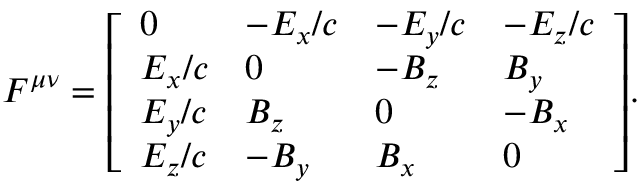Convert formula to latex. <formula><loc_0><loc_0><loc_500><loc_500>F ^ { \mu \nu } = { \left [ \begin{array} { l l l l } { 0 } & { - E _ { x } / c } & { - E _ { y } / c } & { - E _ { z } / c } \\ { E _ { x } / c } & { 0 } & { - B _ { z } } & { B _ { y } } \\ { E _ { y } / c } & { B _ { z } } & { 0 } & { - B _ { x } } \\ { E _ { z } / c } & { - B _ { y } } & { B _ { x } } & { 0 } \end{array} \right ] } .</formula> 